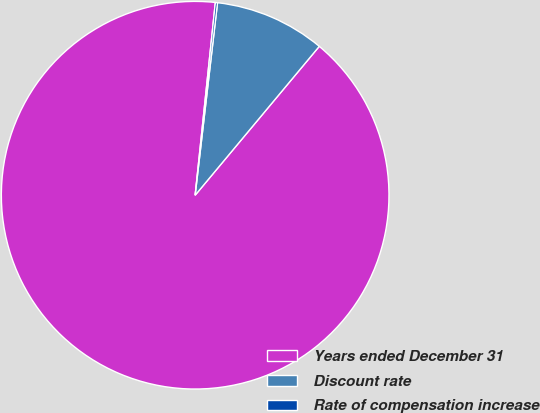Convert chart. <chart><loc_0><loc_0><loc_500><loc_500><pie_chart><fcel>Years ended December 31<fcel>Discount rate<fcel>Rate of compensation increase<nl><fcel>90.6%<fcel>9.22%<fcel>0.18%<nl></chart> 